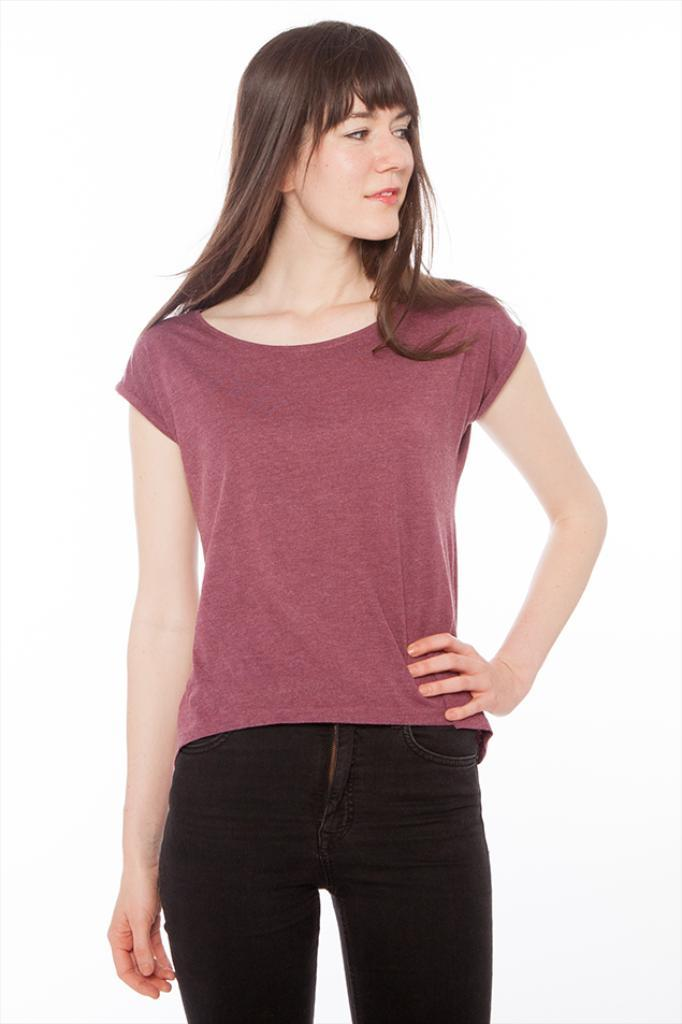What is the main subject of the image? There is a woman standing in the image. What can be seen in the background of the image? The background of the image is white. How many balls are being pushed by the woman in the image? There are no balls or any indication of pushing in the image; it only features a woman standing in front of a white background. 